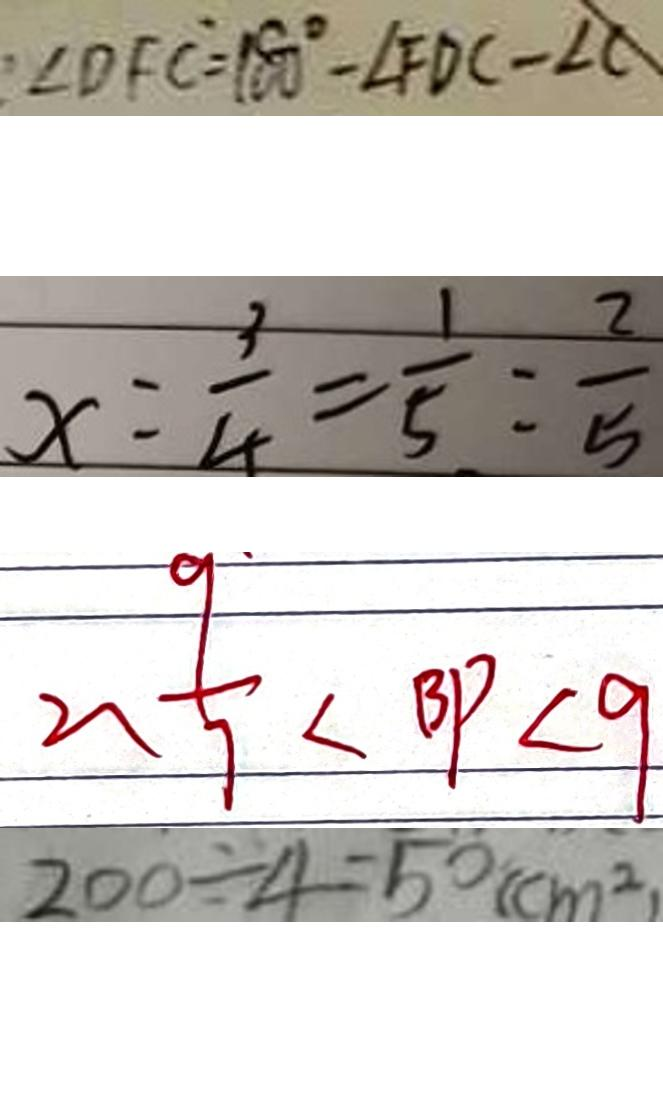<formula> <loc_0><loc_0><loc_500><loc_500>\angle D F C = 1 8 0 ^ { \circ } - \angle F D C - \angle C 
 x = \frac { 3 } { 4 } = \frac { 1 } { 5 } o l o n \frac { 2 } { 5 } 
 2 、 \frac { 9 } { 7 } < B P < 9 
 2 0 0 \div 4 = 5 0 ( c m ^ { 2 } )</formula> 